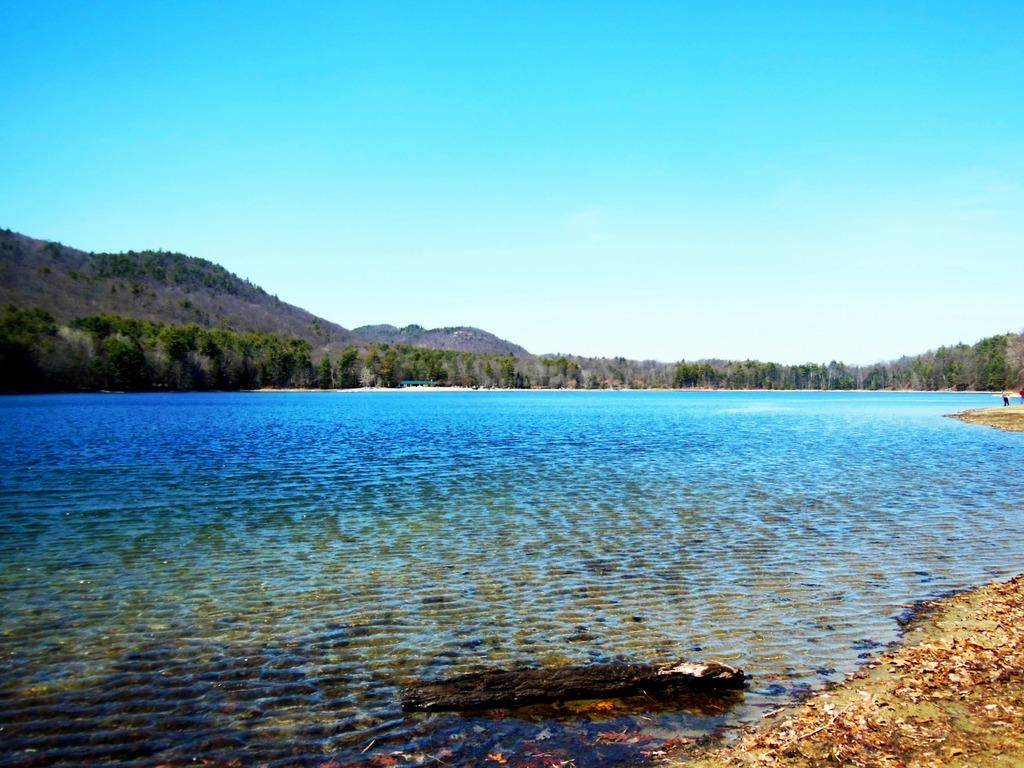What type of natural feature is present in the image? There is a river in the image. What can be seen in the distance behind the river? There are trees and mountains in the background of the image. What color is the sky in the image? The sky is blue in the image. How is the temper of the water in the river being regulated in the image? There is no information about the temperature of the water in the image, nor is there any indication of any mechanism for regulating it. 